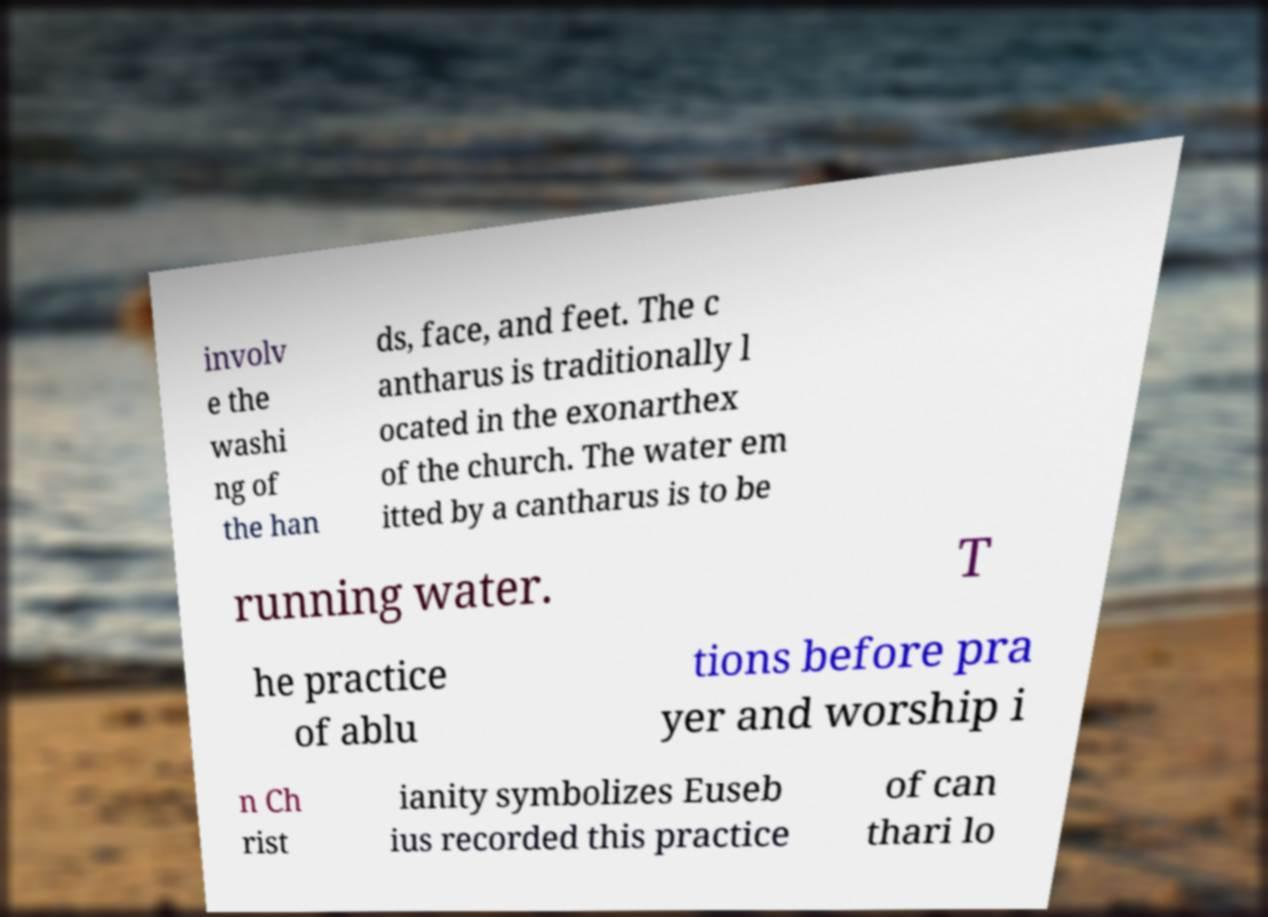What messages or text are displayed in this image? I need them in a readable, typed format. involv e the washi ng of the han ds, face, and feet. The c antharus is traditionally l ocated in the exonarthex of the church. The water em itted by a cantharus is to be running water. T he practice of ablu tions before pra yer and worship i n Ch rist ianity symbolizes Euseb ius recorded this practice of can thari lo 